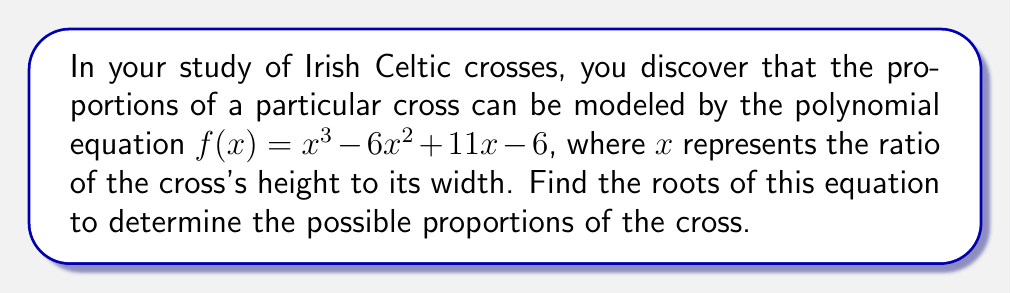Can you answer this question? To find the roots of the polynomial equation $f(x) = x^3 - 6x^2 + 11x - 6$, we'll use the rational root theorem and synthetic division.

Step 1: List possible rational roots
The possible rational roots are the factors of the constant term (6): ±1, ±2, ±3, ±6

Step 2: Test potential roots using synthetic division
Let's start with x = 1:

$$ 1 | 1 \quad -6 \quad 11 \quad -6 $$
$$ \quad\quad 1 \quad -5 \quad 6 $$
$$ 1 \quad -5 \quad 6 \quad 0 $$

Since the remainder is 0, x = 1 is a root.

Step 3: Factor out (x - 1)
$f(x) = (x - 1)(x^2 - 5x + 6)$

Step 4: Solve the quadratic equation $x^2 - 5x + 6 = 0$
Using the quadratic formula: $x = \frac{-b \pm \sqrt{b^2 - 4ac}}{2a}$

$x = \frac{5 \pm \sqrt{25 - 24}}{2} = \frac{5 \pm 1}{2}$

This gives us the other two roots: $x = 3$ and $x = 2$

Therefore, the roots of the equation are 1, 2, and 3.
Answer: 1, 2, 3 